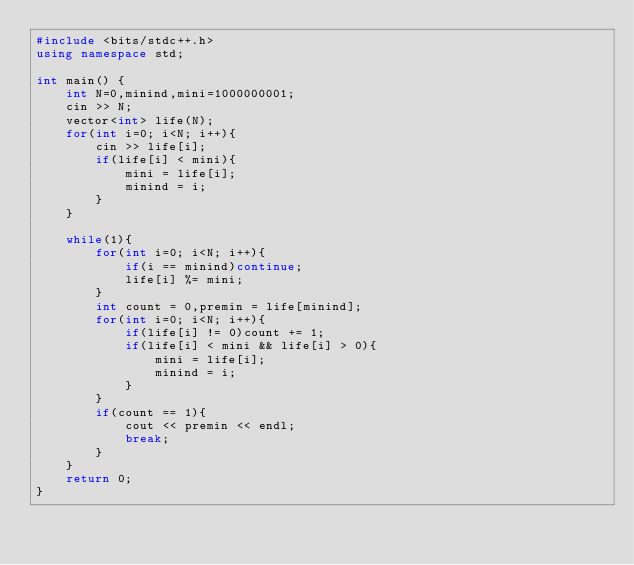<code> <loc_0><loc_0><loc_500><loc_500><_C++_>#include <bits/stdc++.h>
using namespace std;

int main() {
    int N=0,minind,mini=1000000001;
    cin >> N;
    vector<int> life(N);
    for(int i=0; i<N; i++){
        cin >> life[i];
        if(life[i] < mini){
            mini = life[i];
            minind = i;
        }
    }

    while(1){
        for(int i=0; i<N; i++){
            if(i == minind)continue;
            life[i] %= mini;
        }
        int count = 0,premin = life[minind];
        for(int i=0; i<N; i++){
            if(life[i] != 0)count += 1;
            if(life[i] < mini && life[i] > 0){
                mini = life[i];
                minind = i;
            }
        }
        if(count == 1){
            cout << premin << endl;
            break;
        }
    }
    return 0;
}</code> 